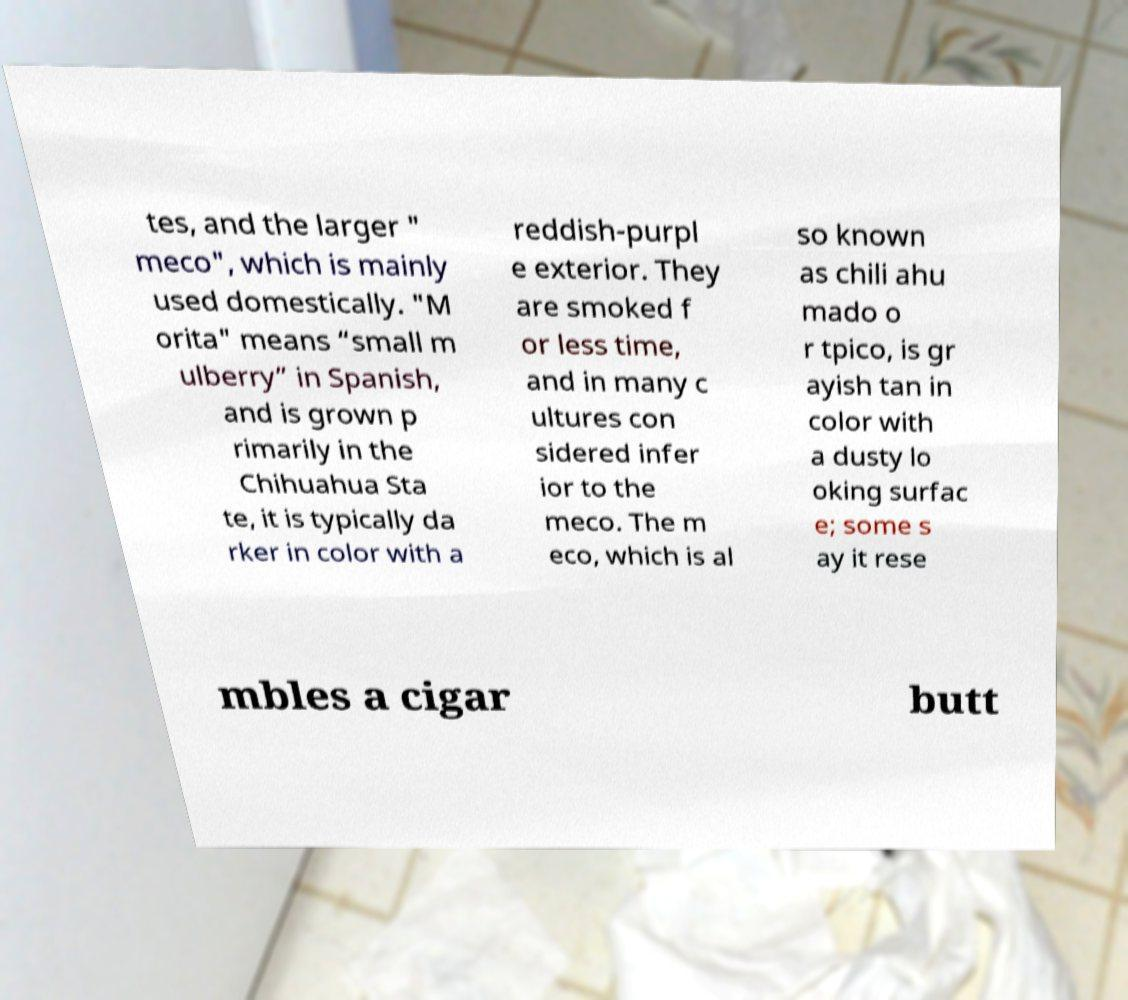Please identify and transcribe the text found in this image. tes, and the larger " meco", which is mainly used domestically. "M orita" means “small m ulberry” in Spanish, and is grown p rimarily in the Chihuahua Sta te, it is typically da rker in color with a reddish-purpl e exterior. They are smoked f or less time, and in many c ultures con sidered infer ior to the meco. The m eco, which is al so known as chili ahu mado o r tpico, is gr ayish tan in color with a dusty lo oking surfac e; some s ay it rese mbles a cigar butt 